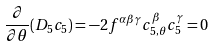<formula> <loc_0><loc_0><loc_500><loc_500>\frac { \partial } { \partial \theta } ( D _ { 5 } c _ { 5 } ) = - 2 f ^ { \alpha \beta \gamma } c _ { 5 , \theta } ^ { \beta } c _ { 5 } ^ { \gamma } = 0</formula> 